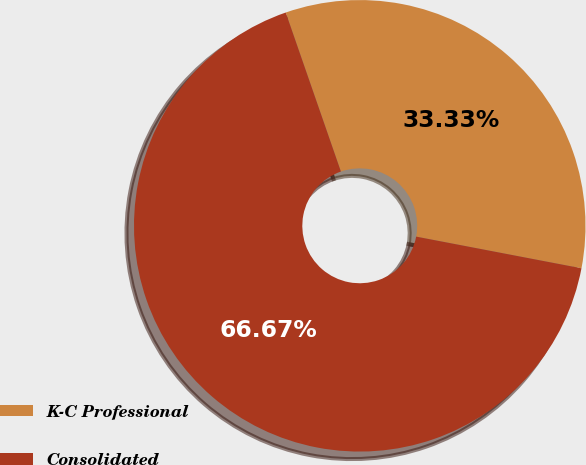<chart> <loc_0><loc_0><loc_500><loc_500><pie_chart><fcel>K-C Professional<fcel>Consolidated<nl><fcel>33.33%<fcel>66.67%<nl></chart> 